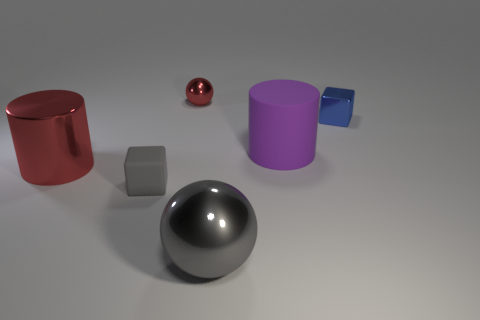Add 1 large purple cylinders. How many objects exist? 7 Subtract 1 cubes. How many cubes are left? 1 Add 5 small metal cubes. How many small metal cubes exist? 6 Subtract 0 blue cylinders. How many objects are left? 6 Subtract all metal cylinders. Subtract all small metallic things. How many objects are left? 3 Add 1 blocks. How many blocks are left? 3 